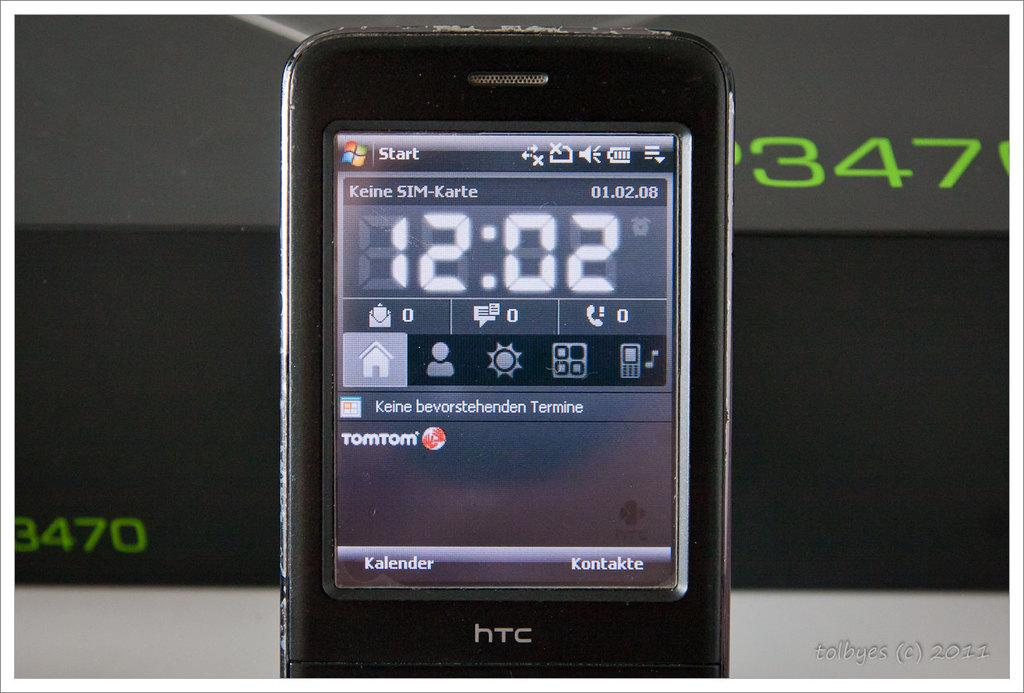<image>
Relay a brief, clear account of the picture shown. Old HTC cellphone with a start button on the top and the time showing 12:02. 